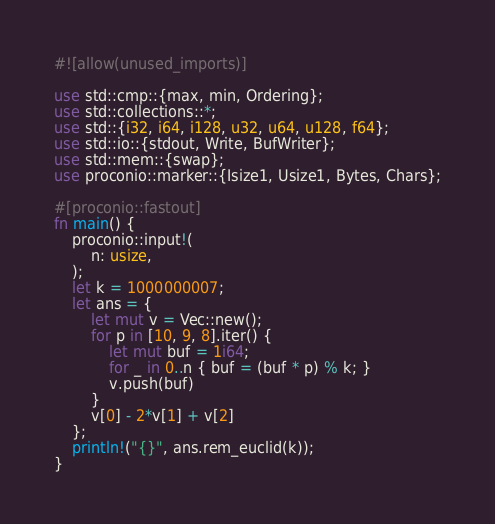<code> <loc_0><loc_0><loc_500><loc_500><_Rust_>#![allow(unused_imports)]

use std::cmp::{max, min, Ordering};
use std::collections::*;
use std::{i32, i64, i128, u32, u64, u128, f64};
use std::io::{stdout, Write, BufWriter};
use std::mem::{swap};
use proconio::marker::{Isize1, Usize1, Bytes, Chars};

#[proconio::fastout]
fn main() {
    proconio::input!(
        n: usize,
    );
    let k = 1000000007;
    let ans = {
        let mut v = Vec::new();
        for p in [10, 9, 8].iter() {
            let mut buf = 1i64;
            for _ in 0..n { buf = (buf * p) % k; }
            v.push(buf)
        }
        v[0] - 2*v[1] + v[2]
    };
    println!("{}", ans.rem_euclid(k));
}

</code> 